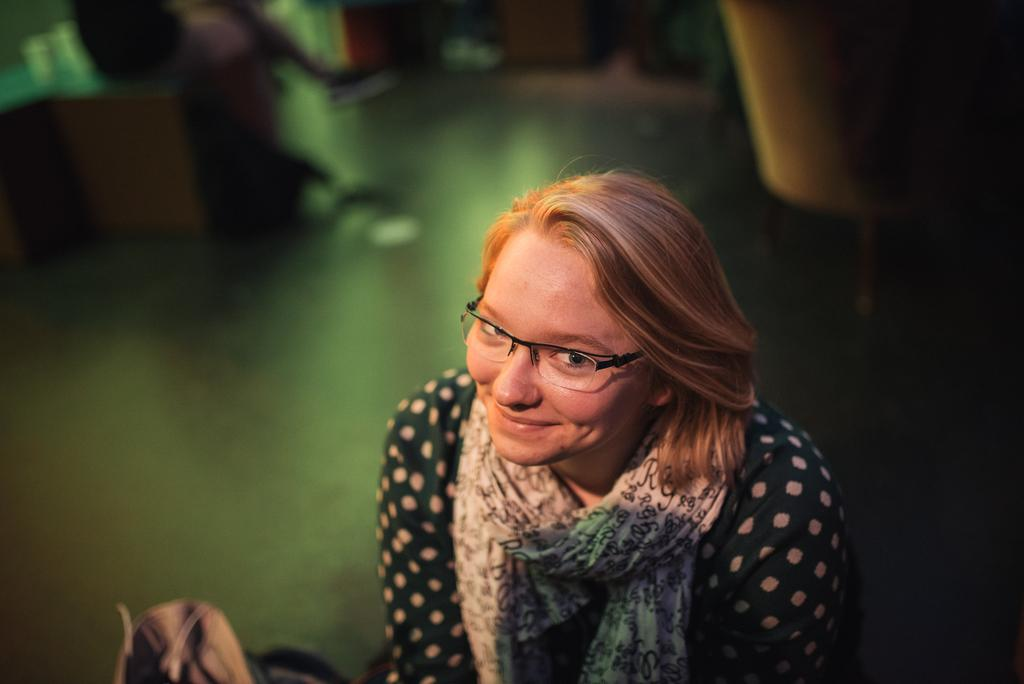What is the main subject of the image? The main subject of the image is a woman. What is the woman wearing in the image? The woman is wearing a scarf and spectacles in the image. What is the woman's facial expression in the image? The woman is smiling in the image. Can you describe the background of the image? The background of the image is blurred. What type of shock can be seen affecting the woman's brain in the image? There is no indication of a shock or any effect on the woman's brain in the image. 